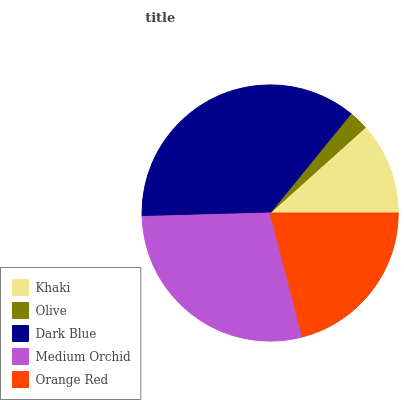Is Olive the minimum?
Answer yes or no. Yes. Is Dark Blue the maximum?
Answer yes or no. Yes. Is Dark Blue the minimum?
Answer yes or no. No. Is Olive the maximum?
Answer yes or no. No. Is Dark Blue greater than Olive?
Answer yes or no. Yes. Is Olive less than Dark Blue?
Answer yes or no. Yes. Is Olive greater than Dark Blue?
Answer yes or no. No. Is Dark Blue less than Olive?
Answer yes or no. No. Is Orange Red the high median?
Answer yes or no. Yes. Is Orange Red the low median?
Answer yes or no. Yes. Is Khaki the high median?
Answer yes or no. No. Is Khaki the low median?
Answer yes or no. No. 